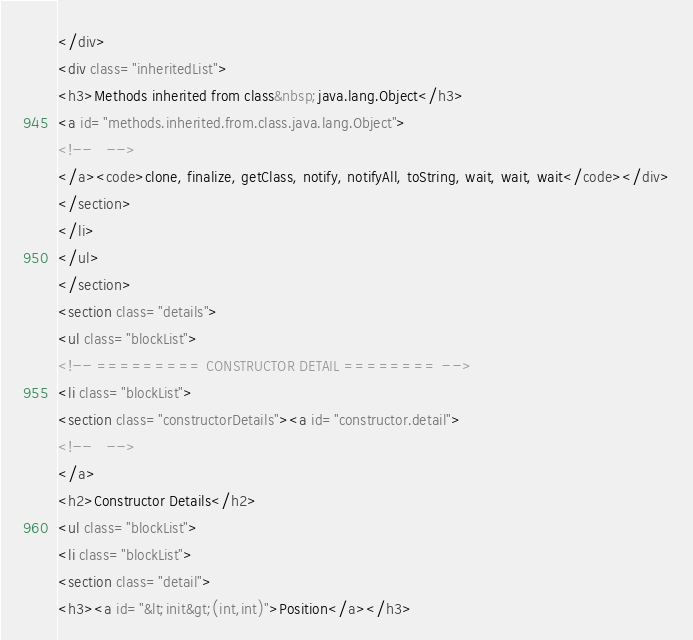<code> <loc_0><loc_0><loc_500><loc_500><_HTML_></div>
<div class="inheritedList">
<h3>Methods inherited from class&nbsp;java.lang.Object</h3>
<a id="methods.inherited.from.class.java.lang.Object">
<!--   -->
</a><code>clone, finalize, getClass, notify, notifyAll, toString, wait, wait, wait</code></div>
</section>
</li>
</ul>
</section>
<section class="details">
<ul class="blockList">
<!-- ========= CONSTRUCTOR DETAIL ======== -->
<li class="blockList">
<section class="constructorDetails"><a id="constructor.detail">
<!--   -->
</a>
<h2>Constructor Details</h2>
<ul class="blockList">
<li class="blockList">
<section class="detail">
<h3><a id="&lt;init&gt;(int,int)">Position</a></h3></code> 